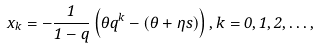Convert formula to latex. <formula><loc_0><loc_0><loc_500><loc_500>x _ { k } = - \frac { 1 } { 1 - q } \left ( \theta q ^ { k } - ( \theta + \eta s ) \right ) , k = 0 , 1 , 2 , \dots ,</formula> 